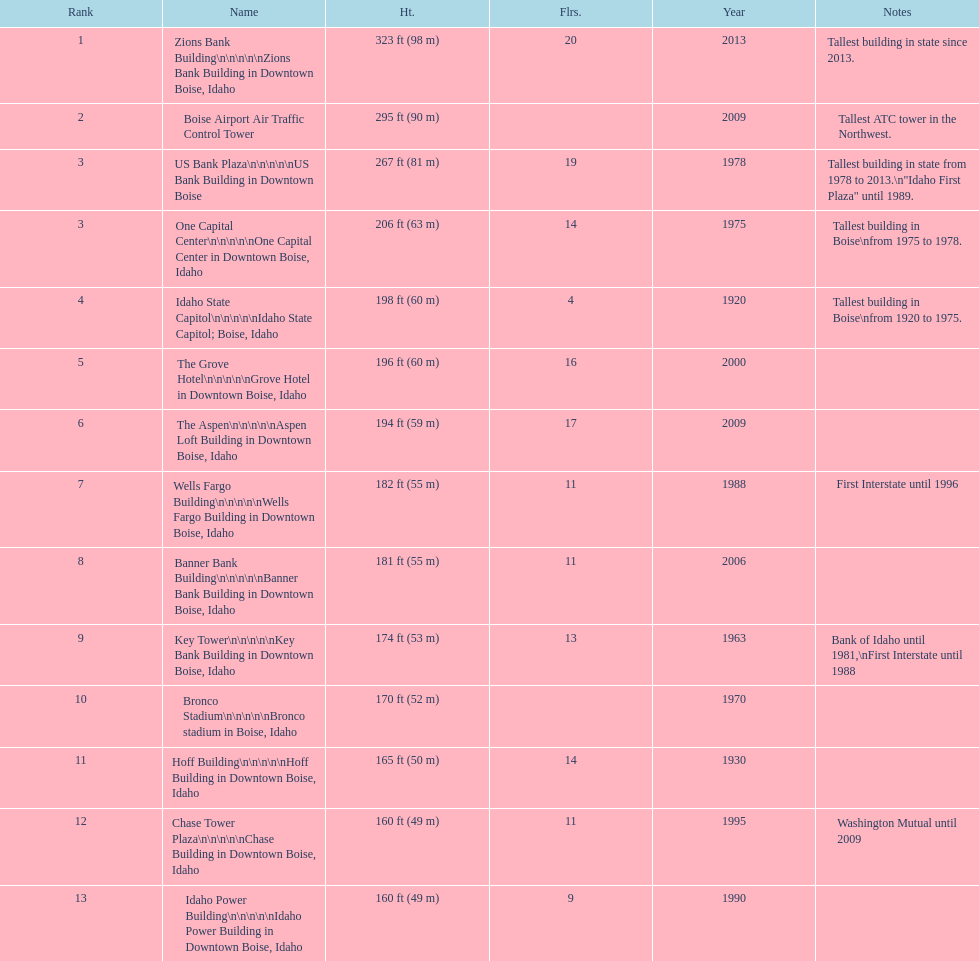Is the bronco stadium above or below 150 ft? Above. 